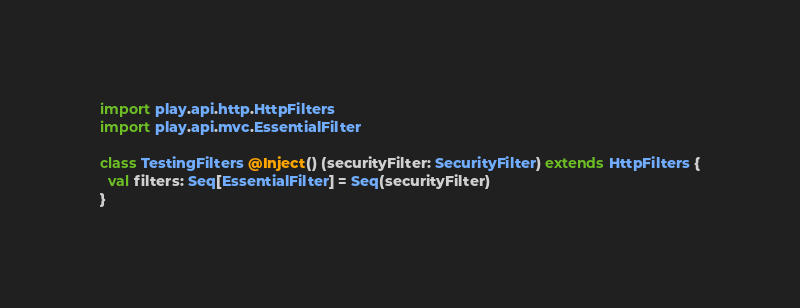<code> <loc_0><loc_0><loc_500><loc_500><_Scala_>
import play.api.http.HttpFilters
import play.api.mvc.EssentialFilter

class TestingFilters @Inject() (securityFilter: SecurityFilter) extends HttpFilters {
  val filters: Seq[EssentialFilter] = Seq(securityFilter)
}
</code> 